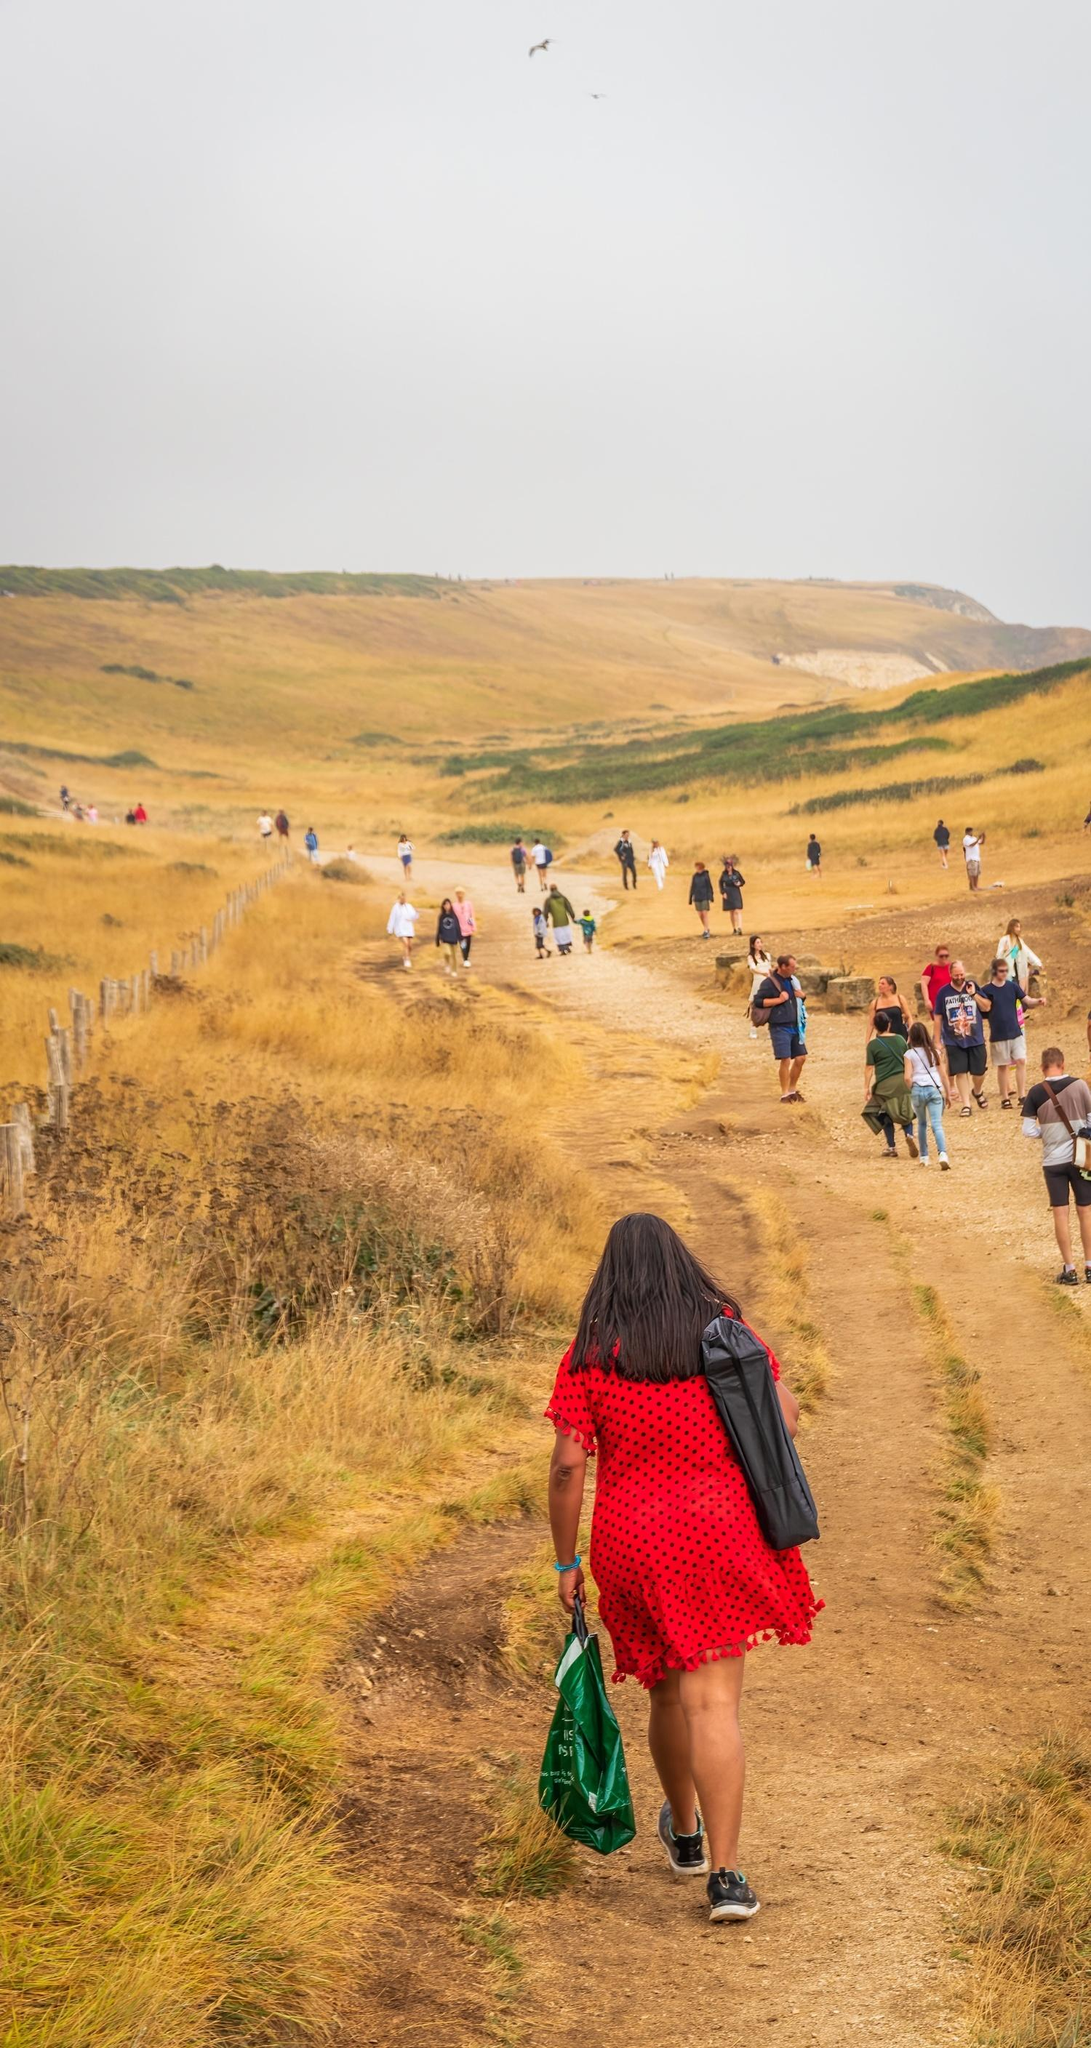What's happening in the scene? In the image, a considerable number of people are walking through a picturesque countryside path that stretches out into the distance. The path is a dirt trail lined by arid, golden grass on both sides and is demarcated on the right by a rustic wooden fence. To the left, gentle hills rise and fall, adding a sense of natural undulations to the landscape.

The sky overhead is cloudy, with a few birds soaring high above, hinting at a peaceful, yet possibly overcast day. The wind appears to be calm, and the overall ambiance is serene.

Leading the procession is a person dressed vibrantly in a red dress with a green bag in hand. The group she leads follows casually, suggesting a leisurely outing or a communal hike. Their relaxed casual attire supports the notion of a day dedicated to enjoying nature and each other’s company. The foreground features this leader vividly, while the background showcases the group scattered along the trail in a relaxed manner.

No distinct text is visible in the image. The image composition effectively places focus on the human element of the scene with a balanced depth of field showcasing the people, the fence and the terrain in the midground, and the expansive sky in the background. Overall, it captures a moment of companionship and simple joy amid the splendor of nature. 